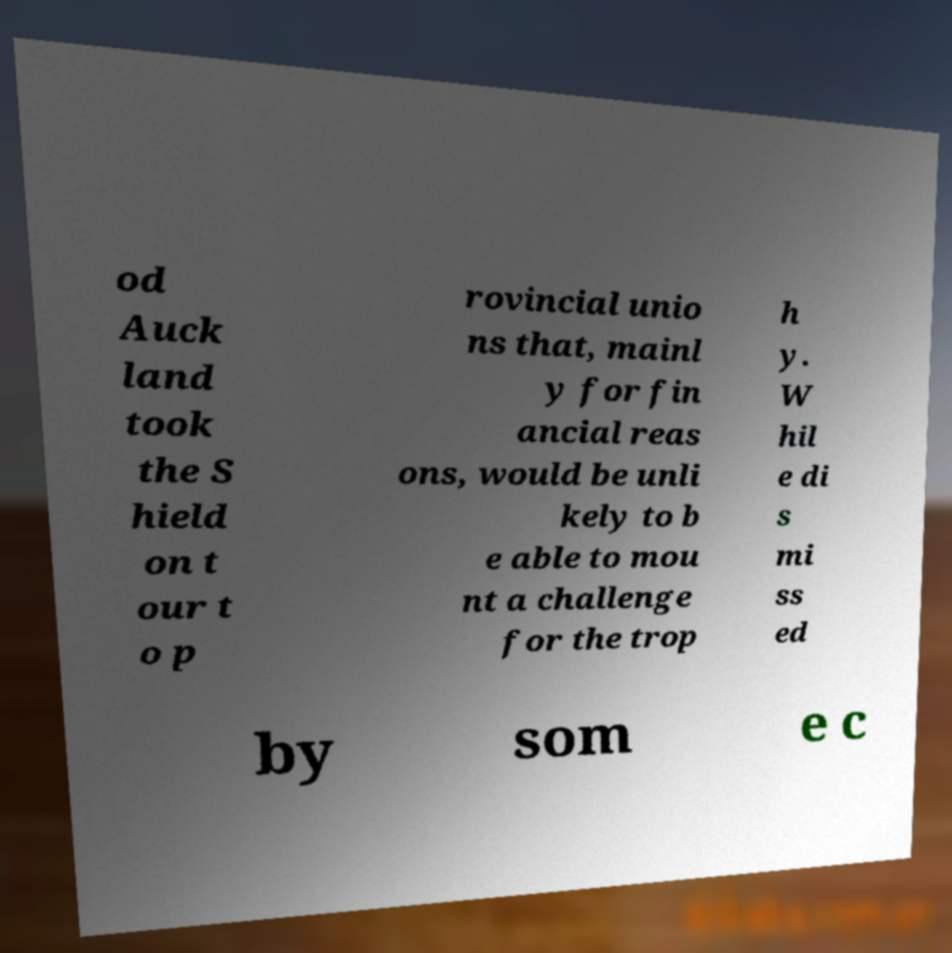Please read and relay the text visible in this image. What does it say? od Auck land took the S hield on t our t o p rovincial unio ns that, mainl y for fin ancial reas ons, would be unli kely to b e able to mou nt a challenge for the trop h y. W hil e di s mi ss ed by som e c 